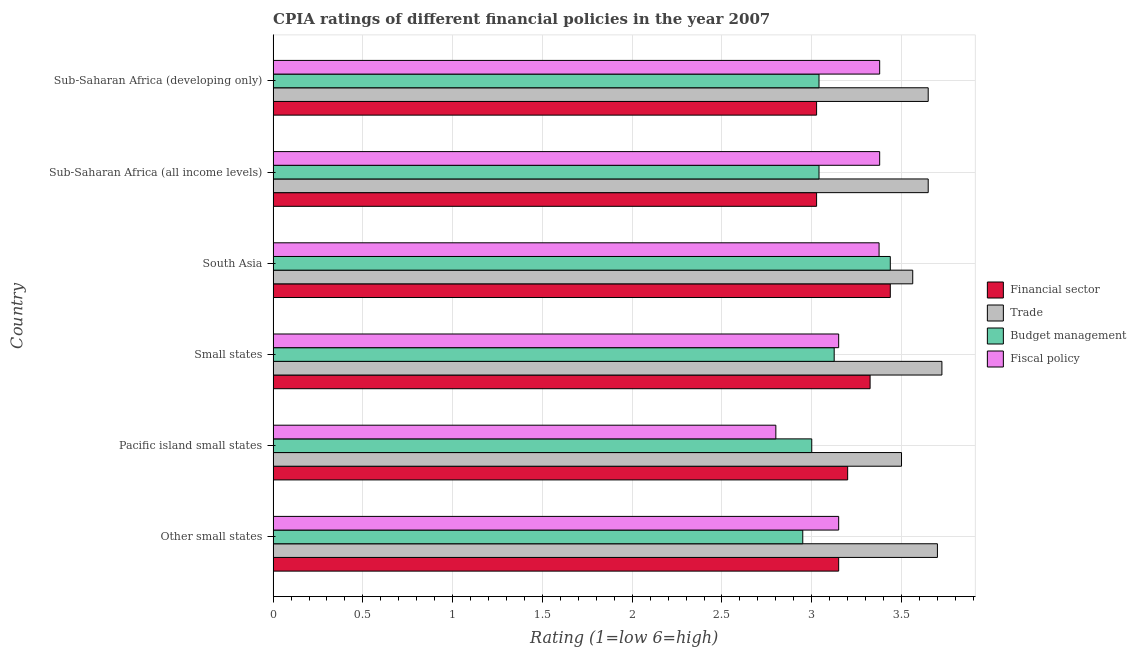How many different coloured bars are there?
Make the answer very short. 4. How many bars are there on the 5th tick from the top?
Offer a terse response. 4. How many bars are there on the 1st tick from the bottom?
Offer a very short reply. 4. What is the label of the 3rd group of bars from the top?
Make the answer very short. South Asia. In how many cases, is the number of bars for a given country not equal to the number of legend labels?
Your answer should be compact. 0. What is the cpia rating of financial sector in Small states?
Give a very brief answer. 3.33. Across all countries, what is the maximum cpia rating of trade?
Give a very brief answer. 3.73. In which country was the cpia rating of fiscal policy maximum?
Give a very brief answer. Sub-Saharan Africa (all income levels). In which country was the cpia rating of fiscal policy minimum?
Your response must be concise. Pacific island small states. What is the total cpia rating of trade in the graph?
Keep it short and to the point. 21.78. What is the difference between the cpia rating of financial sector in Pacific island small states and that in Small states?
Offer a very short reply. -0.12. What is the difference between the cpia rating of budget management in Sub-Saharan Africa (developing only) and the cpia rating of trade in Other small states?
Keep it short and to the point. -0.66. What is the average cpia rating of trade per country?
Offer a terse response. 3.63. What is the difference between the cpia rating of financial sector and cpia rating of budget management in Sub-Saharan Africa (all income levels)?
Provide a succinct answer. -0.01. What is the ratio of the cpia rating of trade in South Asia to that in Sub-Saharan Africa (developing only)?
Make the answer very short. 0.98. What is the difference between the highest and the second highest cpia rating of fiscal policy?
Offer a terse response. 0. What is the difference between the highest and the lowest cpia rating of fiscal policy?
Your answer should be very brief. 0.58. Is the sum of the cpia rating of financial sector in South Asia and Sub-Saharan Africa (developing only) greater than the maximum cpia rating of fiscal policy across all countries?
Give a very brief answer. Yes. What does the 1st bar from the top in Other small states represents?
Make the answer very short. Fiscal policy. What does the 4th bar from the bottom in Other small states represents?
Your answer should be very brief. Fiscal policy. Is it the case that in every country, the sum of the cpia rating of financial sector and cpia rating of trade is greater than the cpia rating of budget management?
Offer a terse response. Yes. How many bars are there?
Provide a succinct answer. 24. Are all the bars in the graph horizontal?
Keep it short and to the point. Yes. Are the values on the major ticks of X-axis written in scientific E-notation?
Provide a succinct answer. No. What is the title of the graph?
Provide a succinct answer. CPIA ratings of different financial policies in the year 2007. What is the label or title of the Y-axis?
Provide a succinct answer. Country. What is the Rating (1=low 6=high) in Financial sector in Other small states?
Give a very brief answer. 3.15. What is the Rating (1=low 6=high) of Trade in Other small states?
Provide a short and direct response. 3.7. What is the Rating (1=low 6=high) in Budget management in Other small states?
Provide a succinct answer. 2.95. What is the Rating (1=low 6=high) of Fiscal policy in Other small states?
Provide a short and direct response. 3.15. What is the Rating (1=low 6=high) of Trade in Pacific island small states?
Your answer should be very brief. 3.5. What is the Rating (1=low 6=high) in Fiscal policy in Pacific island small states?
Ensure brevity in your answer.  2.8. What is the Rating (1=low 6=high) in Financial sector in Small states?
Your answer should be very brief. 3.33. What is the Rating (1=low 6=high) of Trade in Small states?
Offer a terse response. 3.73. What is the Rating (1=low 6=high) of Budget management in Small states?
Keep it short and to the point. 3.12. What is the Rating (1=low 6=high) of Fiscal policy in Small states?
Keep it short and to the point. 3.15. What is the Rating (1=low 6=high) of Financial sector in South Asia?
Make the answer very short. 3.44. What is the Rating (1=low 6=high) in Trade in South Asia?
Keep it short and to the point. 3.56. What is the Rating (1=low 6=high) in Budget management in South Asia?
Give a very brief answer. 3.44. What is the Rating (1=low 6=high) in Fiscal policy in South Asia?
Provide a succinct answer. 3.38. What is the Rating (1=low 6=high) of Financial sector in Sub-Saharan Africa (all income levels)?
Make the answer very short. 3.03. What is the Rating (1=low 6=high) of Trade in Sub-Saharan Africa (all income levels)?
Give a very brief answer. 3.65. What is the Rating (1=low 6=high) in Budget management in Sub-Saharan Africa (all income levels)?
Make the answer very short. 3.04. What is the Rating (1=low 6=high) of Fiscal policy in Sub-Saharan Africa (all income levels)?
Provide a succinct answer. 3.38. What is the Rating (1=low 6=high) of Financial sector in Sub-Saharan Africa (developing only)?
Keep it short and to the point. 3.03. What is the Rating (1=low 6=high) of Trade in Sub-Saharan Africa (developing only)?
Ensure brevity in your answer.  3.65. What is the Rating (1=low 6=high) in Budget management in Sub-Saharan Africa (developing only)?
Your answer should be very brief. 3.04. What is the Rating (1=low 6=high) in Fiscal policy in Sub-Saharan Africa (developing only)?
Ensure brevity in your answer.  3.38. Across all countries, what is the maximum Rating (1=low 6=high) in Financial sector?
Your answer should be very brief. 3.44. Across all countries, what is the maximum Rating (1=low 6=high) in Trade?
Your response must be concise. 3.73. Across all countries, what is the maximum Rating (1=low 6=high) in Budget management?
Your answer should be compact. 3.44. Across all countries, what is the maximum Rating (1=low 6=high) of Fiscal policy?
Offer a very short reply. 3.38. Across all countries, what is the minimum Rating (1=low 6=high) in Financial sector?
Make the answer very short. 3.03. Across all countries, what is the minimum Rating (1=low 6=high) of Trade?
Offer a terse response. 3.5. Across all countries, what is the minimum Rating (1=low 6=high) in Budget management?
Your answer should be compact. 2.95. What is the total Rating (1=low 6=high) of Financial sector in the graph?
Make the answer very short. 19.17. What is the total Rating (1=low 6=high) in Trade in the graph?
Your response must be concise. 21.78. What is the total Rating (1=low 6=high) of Budget management in the graph?
Make the answer very short. 18.59. What is the total Rating (1=low 6=high) of Fiscal policy in the graph?
Offer a terse response. 19.23. What is the difference between the Rating (1=low 6=high) of Financial sector in Other small states and that in Pacific island small states?
Your answer should be compact. -0.05. What is the difference between the Rating (1=low 6=high) of Trade in Other small states and that in Pacific island small states?
Your response must be concise. 0.2. What is the difference between the Rating (1=low 6=high) of Fiscal policy in Other small states and that in Pacific island small states?
Your answer should be compact. 0.35. What is the difference between the Rating (1=low 6=high) of Financial sector in Other small states and that in Small states?
Ensure brevity in your answer.  -0.17. What is the difference between the Rating (1=low 6=high) of Trade in Other small states and that in Small states?
Provide a short and direct response. -0.03. What is the difference between the Rating (1=low 6=high) in Budget management in Other small states and that in Small states?
Give a very brief answer. -0.17. What is the difference between the Rating (1=low 6=high) of Financial sector in Other small states and that in South Asia?
Keep it short and to the point. -0.29. What is the difference between the Rating (1=low 6=high) in Trade in Other small states and that in South Asia?
Your answer should be compact. 0.14. What is the difference between the Rating (1=low 6=high) in Budget management in Other small states and that in South Asia?
Your response must be concise. -0.49. What is the difference between the Rating (1=low 6=high) of Fiscal policy in Other small states and that in South Asia?
Your answer should be compact. -0.23. What is the difference between the Rating (1=low 6=high) of Financial sector in Other small states and that in Sub-Saharan Africa (all income levels)?
Offer a very short reply. 0.12. What is the difference between the Rating (1=low 6=high) of Trade in Other small states and that in Sub-Saharan Africa (all income levels)?
Provide a succinct answer. 0.05. What is the difference between the Rating (1=low 6=high) in Budget management in Other small states and that in Sub-Saharan Africa (all income levels)?
Ensure brevity in your answer.  -0.09. What is the difference between the Rating (1=low 6=high) of Fiscal policy in Other small states and that in Sub-Saharan Africa (all income levels)?
Make the answer very short. -0.23. What is the difference between the Rating (1=low 6=high) in Financial sector in Other small states and that in Sub-Saharan Africa (developing only)?
Give a very brief answer. 0.12. What is the difference between the Rating (1=low 6=high) in Trade in Other small states and that in Sub-Saharan Africa (developing only)?
Provide a short and direct response. 0.05. What is the difference between the Rating (1=low 6=high) of Budget management in Other small states and that in Sub-Saharan Africa (developing only)?
Offer a very short reply. -0.09. What is the difference between the Rating (1=low 6=high) in Fiscal policy in Other small states and that in Sub-Saharan Africa (developing only)?
Ensure brevity in your answer.  -0.23. What is the difference between the Rating (1=low 6=high) of Financial sector in Pacific island small states and that in Small states?
Your answer should be compact. -0.12. What is the difference between the Rating (1=low 6=high) in Trade in Pacific island small states and that in Small states?
Your answer should be compact. -0.23. What is the difference between the Rating (1=low 6=high) in Budget management in Pacific island small states and that in Small states?
Make the answer very short. -0.12. What is the difference between the Rating (1=low 6=high) of Fiscal policy in Pacific island small states and that in Small states?
Give a very brief answer. -0.35. What is the difference between the Rating (1=low 6=high) in Financial sector in Pacific island small states and that in South Asia?
Keep it short and to the point. -0.24. What is the difference between the Rating (1=low 6=high) of Trade in Pacific island small states and that in South Asia?
Make the answer very short. -0.06. What is the difference between the Rating (1=low 6=high) in Budget management in Pacific island small states and that in South Asia?
Ensure brevity in your answer.  -0.44. What is the difference between the Rating (1=low 6=high) of Fiscal policy in Pacific island small states and that in South Asia?
Your answer should be compact. -0.57. What is the difference between the Rating (1=low 6=high) in Financial sector in Pacific island small states and that in Sub-Saharan Africa (all income levels)?
Ensure brevity in your answer.  0.17. What is the difference between the Rating (1=low 6=high) in Trade in Pacific island small states and that in Sub-Saharan Africa (all income levels)?
Your answer should be compact. -0.15. What is the difference between the Rating (1=low 6=high) in Budget management in Pacific island small states and that in Sub-Saharan Africa (all income levels)?
Your answer should be compact. -0.04. What is the difference between the Rating (1=low 6=high) of Fiscal policy in Pacific island small states and that in Sub-Saharan Africa (all income levels)?
Offer a very short reply. -0.58. What is the difference between the Rating (1=low 6=high) of Financial sector in Pacific island small states and that in Sub-Saharan Africa (developing only)?
Your answer should be very brief. 0.17. What is the difference between the Rating (1=low 6=high) of Trade in Pacific island small states and that in Sub-Saharan Africa (developing only)?
Offer a very short reply. -0.15. What is the difference between the Rating (1=low 6=high) of Budget management in Pacific island small states and that in Sub-Saharan Africa (developing only)?
Your answer should be compact. -0.04. What is the difference between the Rating (1=low 6=high) in Fiscal policy in Pacific island small states and that in Sub-Saharan Africa (developing only)?
Offer a very short reply. -0.58. What is the difference between the Rating (1=low 6=high) of Financial sector in Small states and that in South Asia?
Keep it short and to the point. -0.11. What is the difference between the Rating (1=low 6=high) in Trade in Small states and that in South Asia?
Provide a short and direct response. 0.16. What is the difference between the Rating (1=low 6=high) of Budget management in Small states and that in South Asia?
Your answer should be compact. -0.31. What is the difference between the Rating (1=low 6=high) of Fiscal policy in Small states and that in South Asia?
Your response must be concise. -0.23. What is the difference between the Rating (1=low 6=high) in Financial sector in Small states and that in Sub-Saharan Africa (all income levels)?
Make the answer very short. 0.3. What is the difference between the Rating (1=low 6=high) of Trade in Small states and that in Sub-Saharan Africa (all income levels)?
Ensure brevity in your answer.  0.08. What is the difference between the Rating (1=low 6=high) in Budget management in Small states and that in Sub-Saharan Africa (all income levels)?
Offer a terse response. 0.08. What is the difference between the Rating (1=low 6=high) of Fiscal policy in Small states and that in Sub-Saharan Africa (all income levels)?
Provide a succinct answer. -0.23. What is the difference between the Rating (1=low 6=high) of Financial sector in Small states and that in Sub-Saharan Africa (developing only)?
Offer a very short reply. 0.3. What is the difference between the Rating (1=low 6=high) in Trade in Small states and that in Sub-Saharan Africa (developing only)?
Give a very brief answer. 0.08. What is the difference between the Rating (1=low 6=high) in Budget management in Small states and that in Sub-Saharan Africa (developing only)?
Your answer should be compact. 0.08. What is the difference between the Rating (1=low 6=high) of Fiscal policy in Small states and that in Sub-Saharan Africa (developing only)?
Provide a short and direct response. -0.23. What is the difference between the Rating (1=low 6=high) of Financial sector in South Asia and that in Sub-Saharan Africa (all income levels)?
Offer a very short reply. 0.41. What is the difference between the Rating (1=low 6=high) of Trade in South Asia and that in Sub-Saharan Africa (all income levels)?
Your answer should be very brief. -0.09. What is the difference between the Rating (1=low 6=high) of Budget management in South Asia and that in Sub-Saharan Africa (all income levels)?
Make the answer very short. 0.4. What is the difference between the Rating (1=low 6=high) of Fiscal policy in South Asia and that in Sub-Saharan Africa (all income levels)?
Provide a short and direct response. -0. What is the difference between the Rating (1=low 6=high) of Financial sector in South Asia and that in Sub-Saharan Africa (developing only)?
Keep it short and to the point. 0.41. What is the difference between the Rating (1=low 6=high) of Trade in South Asia and that in Sub-Saharan Africa (developing only)?
Your answer should be very brief. -0.09. What is the difference between the Rating (1=low 6=high) of Budget management in South Asia and that in Sub-Saharan Africa (developing only)?
Your answer should be very brief. 0.4. What is the difference between the Rating (1=low 6=high) of Fiscal policy in South Asia and that in Sub-Saharan Africa (developing only)?
Make the answer very short. -0. What is the difference between the Rating (1=low 6=high) of Financial sector in Sub-Saharan Africa (all income levels) and that in Sub-Saharan Africa (developing only)?
Offer a very short reply. 0. What is the difference between the Rating (1=low 6=high) of Trade in Sub-Saharan Africa (all income levels) and that in Sub-Saharan Africa (developing only)?
Your answer should be very brief. 0. What is the difference between the Rating (1=low 6=high) of Financial sector in Other small states and the Rating (1=low 6=high) of Trade in Pacific island small states?
Make the answer very short. -0.35. What is the difference between the Rating (1=low 6=high) of Financial sector in Other small states and the Rating (1=low 6=high) of Fiscal policy in Pacific island small states?
Offer a terse response. 0.35. What is the difference between the Rating (1=low 6=high) in Trade in Other small states and the Rating (1=low 6=high) in Fiscal policy in Pacific island small states?
Your answer should be very brief. 0.9. What is the difference between the Rating (1=low 6=high) in Budget management in Other small states and the Rating (1=low 6=high) in Fiscal policy in Pacific island small states?
Provide a short and direct response. 0.15. What is the difference between the Rating (1=low 6=high) in Financial sector in Other small states and the Rating (1=low 6=high) in Trade in Small states?
Your answer should be very brief. -0.57. What is the difference between the Rating (1=low 6=high) of Financial sector in Other small states and the Rating (1=low 6=high) of Budget management in Small states?
Give a very brief answer. 0.03. What is the difference between the Rating (1=low 6=high) in Financial sector in Other small states and the Rating (1=low 6=high) in Fiscal policy in Small states?
Provide a succinct answer. 0. What is the difference between the Rating (1=low 6=high) of Trade in Other small states and the Rating (1=low 6=high) of Budget management in Small states?
Make the answer very short. 0.57. What is the difference between the Rating (1=low 6=high) in Trade in Other small states and the Rating (1=low 6=high) in Fiscal policy in Small states?
Provide a succinct answer. 0.55. What is the difference between the Rating (1=low 6=high) of Budget management in Other small states and the Rating (1=low 6=high) of Fiscal policy in Small states?
Provide a succinct answer. -0.2. What is the difference between the Rating (1=low 6=high) in Financial sector in Other small states and the Rating (1=low 6=high) in Trade in South Asia?
Make the answer very short. -0.41. What is the difference between the Rating (1=low 6=high) of Financial sector in Other small states and the Rating (1=low 6=high) of Budget management in South Asia?
Your answer should be compact. -0.29. What is the difference between the Rating (1=low 6=high) of Financial sector in Other small states and the Rating (1=low 6=high) of Fiscal policy in South Asia?
Offer a very short reply. -0.23. What is the difference between the Rating (1=low 6=high) of Trade in Other small states and the Rating (1=low 6=high) of Budget management in South Asia?
Ensure brevity in your answer.  0.26. What is the difference between the Rating (1=low 6=high) of Trade in Other small states and the Rating (1=low 6=high) of Fiscal policy in South Asia?
Your answer should be compact. 0.33. What is the difference between the Rating (1=low 6=high) in Budget management in Other small states and the Rating (1=low 6=high) in Fiscal policy in South Asia?
Ensure brevity in your answer.  -0.42. What is the difference between the Rating (1=low 6=high) in Financial sector in Other small states and the Rating (1=low 6=high) in Trade in Sub-Saharan Africa (all income levels)?
Provide a succinct answer. -0.5. What is the difference between the Rating (1=low 6=high) of Financial sector in Other small states and the Rating (1=low 6=high) of Budget management in Sub-Saharan Africa (all income levels)?
Offer a very short reply. 0.11. What is the difference between the Rating (1=low 6=high) of Financial sector in Other small states and the Rating (1=low 6=high) of Fiscal policy in Sub-Saharan Africa (all income levels)?
Offer a terse response. -0.23. What is the difference between the Rating (1=low 6=high) of Trade in Other small states and the Rating (1=low 6=high) of Budget management in Sub-Saharan Africa (all income levels)?
Provide a short and direct response. 0.66. What is the difference between the Rating (1=low 6=high) in Trade in Other small states and the Rating (1=low 6=high) in Fiscal policy in Sub-Saharan Africa (all income levels)?
Provide a succinct answer. 0.32. What is the difference between the Rating (1=low 6=high) of Budget management in Other small states and the Rating (1=low 6=high) of Fiscal policy in Sub-Saharan Africa (all income levels)?
Make the answer very short. -0.43. What is the difference between the Rating (1=low 6=high) of Financial sector in Other small states and the Rating (1=low 6=high) of Trade in Sub-Saharan Africa (developing only)?
Ensure brevity in your answer.  -0.5. What is the difference between the Rating (1=low 6=high) of Financial sector in Other small states and the Rating (1=low 6=high) of Budget management in Sub-Saharan Africa (developing only)?
Your response must be concise. 0.11. What is the difference between the Rating (1=low 6=high) of Financial sector in Other small states and the Rating (1=low 6=high) of Fiscal policy in Sub-Saharan Africa (developing only)?
Offer a very short reply. -0.23. What is the difference between the Rating (1=low 6=high) of Trade in Other small states and the Rating (1=low 6=high) of Budget management in Sub-Saharan Africa (developing only)?
Give a very brief answer. 0.66. What is the difference between the Rating (1=low 6=high) of Trade in Other small states and the Rating (1=low 6=high) of Fiscal policy in Sub-Saharan Africa (developing only)?
Make the answer very short. 0.32. What is the difference between the Rating (1=low 6=high) of Budget management in Other small states and the Rating (1=low 6=high) of Fiscal policy in Sub-Saharan Africa (developing only)?
Your response must be concise. -0.43. What is the difference between the Rating (1=low 6=high) of Financial sector in Pacific island small states and the Rating (1=low 6=high) of Trade in Small states?
Your answer should be compact. -0.53. What is the difference between the Rating (1=low 6=high) of Financial sector in Pacific island small states and the Rating (1=low 6=high) of Budget management in Small states?
Give a very brief answer. 0.07. What is the difference between the Rating (1=low 6=high) in Financial sector in Pacific island small states and the Rating (1=low 6=high) in Fiscal policy in Small states?
Provide a succinct answer. 0.05. What is the difference between the Rating (1=low 6=high) in Budget management in Pacific island small states and the Rating (1=low 6=high) in Fiscal policy in Small states?
Provide a succinct answer. -0.15. What is the difference between the Rating (1=low 6=high) in Financial sector in Pacific island small states and the Rating (1=low 6=high) in Trade in South Asia?
Ensure brevity in your answer.  -0.36. What is the difference between the Rating (1=low 6=high) in Financial sector in Pacific island small states and the Rating (1=low 6=high) in Budget management in South Asia?
Provide a short and direct response. -0.24. What is the difference between the Rating (1=low 6=high) of Financial sector in Pacific island small states and the Rating (1=low 6=high) of Fiscal policy in South Asia?
Offer a terse response. -0.17. What is the difference between the Rating (1=low 6=high) in Trade in Pacific island small states and the Rating (1=low 6=high) in Budget management in South Asia?
Give a very brief answer. 0.06. What is the difference between the Rating (1=low 6=high) in Budget management in Pacific island small states and the Rating (1=low 6=high) in Fiscal policy in South Asia?
Your answer should be very brief. -0.38. What is the difference between the Rating (1=low 6=high) in Financial sector in Pacific island small states and the Rating (1=low 6=high) in Trade in Sub-Saharan Africa (all income levels)?
Offer a terse response. -0.45. What is the difference between the Rating (1=low 6=high) in Financial sector in Pacific island small states and the Rating (1=low 6=high) in Budget management in Sub-Saharan Africa (all income levels)?
Provide a succinct answer. 0.16. What is the difference between the Rating (1=low 6=high) in Financial sector in Pacific island small states and the Rating (1=low 6=high) in Fiscal policy in Sub-Saharan Africa (all income levels)?
Your answer should be compact. -0.18. What is the difference between the Rating (1=low 6=high) of Trade in Pacific island small states and the Rating (1=low 6=high) of Budget management in Sub-Saharan Africa (all income levels)?
Offer a very short reply. 0.46. What is the difference between the Rating (1=low 6=high) in Trade in Pacific island small states and the Rating (1=low 6=high) in Fiscal policy in Sub-Saharan Africa (all income levels)?
Your answer should be compact. 0.12. What is the difference between the Rating (1=low 6=high) of Budget management in Pacific island small states and the Rating (1=low 6=high) of Fiscal policy in Sub-Saharan Africa (all income levels)?
Offer a very short reply. -0.38. What is the difference between the Rating (1=low 6=high) in Financial sector in Pacific island small states and the Rating (1=low 6=high) in Trade in Sub-Saharan Africa (developing only)?
Your answer should be very brief. -0.45. What is the difference between the Rating (1=low 6=high) of Financial sector in Pacific island small states and the Rating (1=low 6=high) of Budget management in Sub-Saharan Africa (developing only)?
Offer a terse response. 0.16. What is the difference between the Rating (1=low 6=high) in Financial sector in Pacific island small states and the Rating (1=low 6=high) in Fiscal policy in Sub-Saharan Africa (developing only)?
Offer a very short reply. -0.18. What is the difference between the Rating (1=low 6=high) in Trade in Pacific island small states and the Rating (1=low 6=high) in Budget management in Sub-Saharan Africa (developing only)?
Ensure brevity in your answer.  0.46. What is the difference between the Rating (1=low 6=high) of Trade in Pacific island small states and the Rating (1=low 6=high) of Fiscal policy in Sub-Saharan Africa (developing only)?
Ensure brevity in your answer.  0.12. What is the difference between the Rating (1=low 6=high) in Budget management in Pacific island small states and the Rating (1=low 6=high) in Fiscal policy in Sub-Saharan Africa (developing only)?
Provide a short and direct response. -0.38. What is the difference between the Rating (1=low 6=high) of Financial sector in Small states and the Rating (1=low 6=high) of Trade in South Asia?
Give a very brief answer. -0.24. What is the difference between the Rating (1=low 6=high) in Financial sector in Small states and the Rating (1=low 6=high) in Budget management in South Asia?
Provide a short and direct response. -0.11. What is the difference between the Rating (1=low 6=high) in Financial sector in Small states and the Rating (1=low 6=high) in Fiscal policy in South Asia?
Give a very brief answer. -0.05. What is the difference between the Rating (1=low 6=high) in Trade in Small states and the Rating (1=low 6=high) in Budget management in South Asia?
Your response must be concise. 0.29. What is the difference between the Rating (1=low 6=high) of Budget management in Small states and the Rating (1=low 6=high) of Fiscal policy in South Asia?
Offer a very short reply. -0.25. What is the difference between the Rating (1=low 6=high) of Financial sector in Small states and the Rating (1=low 6=high) of Trade in Sub-Saharan Africa (all income levels)?
Make the answer very short. -0.32. What is the difference between the Rating (1=low 6=high) of Financial sector in Small states and the Rating (1=low 6=high) of Budget management in Sub-Saharan Africa (all income levels)?
Give a very brief answer. 0.28. What is the difference between the Rating (1=low 6=high) in Financial sector in Small states and the Rating (1=low 6=high) in Fiscal policy in Sub-Saharan Africa (all income levels)?
Offer a terse response. -0.05. What is the difference between the Rating (1=low 6=high) in Trade in Small states and the Rating (1=low 6=high) in Budget management in Sub-Saharan Africa (all income levels)?
Your response must be concise. 0.68. What is the difference between the Rating (1=low 6=high) of Trade in Small states and the Rating (1=low 6=high) of Fiscal policy in Sub-Saharan Africa (all income levels)?
Make the answer very short. 0.35. What is the difference between the Rating (1=low 6=high) of Budget management in Small states and the Rating (1=low 6=high) of Fiscal policy in Sub-Saharan Africa (all income levels)?
Provide a succinct answer. -0.25. What is the difference between the Rating (1=low 6=high) in Financial sector in Small states and the Rating (1=low 6=high) in Trade in Sub-Saharan Africa (developing only)?
Offer a very short reply. -0.32. What is the difference between the Rating (1=low 6=high) of Financial sector in Small states and the Rating (1=low 6=high) of Budget management in Sub-Saharan Africa (developing only)?
Offer a terse response. 0.28. What is the difference between the Rating (1=low 6=high) in Financial sector in Small states and the Rating (1=low 6=high) in Fiscal policy in Sub-Saharan Africa (developing only)?
Your answer should be very brief. -0.05. What is the difference between the Rating (1=low 6=high) in Trade in Small states and the Rating (1=low 6=high) in Budget management in Sub-Saharan Africa (developing only)?
Provide a short and direct response. 0.68. What is the difference between the Rating (1=low 6=high) in Trade in Small states and the Rating (1=low 6=high) in Fiscal policy in Sub-Saharan Africa (developing only)?
Your answer should be very brief. 0.35. What is the difference between the Rating (1=low 6=high) of Budget management in Small states and the Rating (1=low 6=high) of Fiscal policy in Sub-Saharan Africa (developing only)?
Keep it short and to the point. -0.25. What is the difference between the Rating (1=low 6=high) in Financial sector in South Asia and the Rating (1=low 6=high) in Trade in Sub-Saharan Africa (all income levels)?
Offer a terse response. -0.21. What is the difference between the Rating (1=low 6=high) of Financial sector in South Asia and the Rating (1=low 6=high) of Budget management in Sub-Saharan Africa (all income levels)?
Provide a succinct answer. 0.4. What is the difference between the Rating (1=low 6=high) in Financial sector in South Asia and the Rating (1=low 6=high) in Fiscal policy in Sub-Saharan Africa (all income levels)?
Make the answer very short. 0.06. What is the difference between the Rating (1=low 6=high) in Trade in South Asia and the Rating (1=low 6=high) in Budget management in Sub-Saharan Africa (all income levels)?
Offer a very short reply. 0.52. What is the difference between the Rating (1=low 6=high) in Trade in South Asia and the Rating (1=low 6=high) in Fiscal policy in Sub-Saharan Africa (all income levels)?
Provide a succinct answer. 0.18. What is the difference between the Rating (1=low 6=high) in Budget management in South Asia and the Rating (1=low 6=high) in Fiscal policy in Sub-Saharan Africa (all income levels)?
Offer a very short reply. 0.06. What is the difference between the Rating (1=low 6=high) in Financial sector in South Asia and the Rating (1=low 6=high) in Trade in Sub-Saharan Africa (developing only)?
Your answer should be compact. -0.21. What is the difference between the Rating (1=low 6=high) in Financial sector in South Asia and the Rating (1=low 6=high) in Budget management in Sub-Saharan Africa (developing only)?
Keep it short and to the point. 0.4. What is the difference between the Rating (1=low 6=high) in Financial sector in South Asia and the Rating (1=low 6=high) in Fiscal policy in Sub-Saharan Africa (developing only)?
Offer a very short reply. 0.06. What is the difference between the Rating (1=low 6=high) of Trade in South Asia and the Rating (1=low 6=high) of Budget management in Sub-Saharan Africa (developing only)?
Provide a succinct answer. 0.52. What is the difference between the Rating (1=low 6=high) of Trade in South Asia and the Rating (1=low 6=high) of Fiscal policy in Sub-Saharan Africa (developing only)?
Provide a succinct answer. 0.18. What is the difference between the Rating (1=low 6=high) of Budget management in South Asia and the Rating (1=low 6=high) of Fiscal policy in Sub-Saharan Africa (developing only)?
Make the answer very short. 0.06. What is the difference between the Rating (1=low 6=high) of Financial sector in Sub-Saharan Africa (all income levels) and the Rating (1=low 6=high) of Trade in Sub-Saharan Africa (developing only)?
Keep it short and to the point. -0.62. What is the difference between the Rating (1=low 6=high) in Financial sector in Sub-Saharan Africa (all income levels) and the Rating (1=low 6=high) in Budget management in Sub-Saharan Africa (developing only)?
Your answer should be compact. -0.01. What is the difference between the Rating (1=low 6=high) in Financial sector in Sub-Saharan Africa (all income levels) and the Rating (1=low 6=high) in Fiscal policy in Sub-Saharan Africa (developing only)?
Your answer should be very brief. -0.35. What is the difference between the Rating (1=low 6=high) in Trade in Sub-Saharan Africa (all income levels) and the Rating (1=low 6=high) in Budget management in Sub-Saharan Africa (developing only)?
Provide a short and direct response. 0.61. What is the difference between the Rating (1=low 6=high) in Trade in Sub-Saharan Africa (all income levels) and the Rating (1=low 6=high) in Fiscal policy in Sub-Saharan Africa (developing only)?
Offer a terse response. 0.27. What is the difference between the Rating (1=low 6=high) in Budget management in Sub-Saharan Africa (all income levels) and the Rating (1=low 6=high) in Fiscal policy in Sub-Saharan Africa (developing only)?
Give a very brief answer. -0.34. What is the average Rating (1=low 6=high) of Financial sector per country?
Your response must be concise. 3.19. What is the average Rating (1=low 6=high) of Trade per country?
Offer a very short reply. 3.63. What is the average Rating (1=low 6=high) of Budget management per country?
Offer a very short reply. 3.1. What is the average Rating (1=low 6=high) of Fiscal policy per country?
Your answer should be very brief. 3.21. What is the difference between the Rating (1=low 6=high) in Financial sector and Rating (1=low 6=high) in Trade in Other small states?
Provide a short and direct response. -0.55. What is the difference between the Rating (1=low 6=high) in Trade and Rating (1=low 6=high) in Fiscal policy in Other small states?
Ensure brevity in your answer.  0.55. What is the difference between the Rating (1=low 6=high) of Budget management and Rating (1=low 6=high) of Fiscal policy in Other small states?
Your answer should be very brief. -0.2. What is the difference between the Rating (1=low 6=high) of Financial sector and Rating (1=low 6=high) of Fiscal policy in Pacific island small states?
Give a very brief answer. 0.4. What is the difference between the Rating (1=low 6=high) of Trade and Rating (1=low 6=high) of Fiscal policy in Pacific island small states?
Ensure brevity in your answer.  0.7. What is the difference between the Rating (1=low 6=high) of Financial sector and Rating (1=low 6=high) of Fiscal policy in Small states?
Your response must be concise. 0.17. What is the difference between the Rating (1=low 6=high) of Trade and Rating (1=low 6=high) of Budget management in Small states?
Your answer should be compact. 0.6. What is the difference between the Rating (1=low 6=high) of Trade and Rating (1=low 6=high) of Fiscal policy in Small states?
Make the answer very short. 0.57. What is the difference between the Rating (1=low 6=high) in Budget management and Rating (1=low 6=high) in Fiscal policy in Small states?
Make the answer very short. -0.03. What is the difference between the Rating (1=low 6=high) in Financial sector and Rating (1=low 6=high) in Trade in South Asia?
Offer a terse response. -0.12. What is the difference between the Rating (1=low 6=high) in Financial sector and Rating (1=low 6=high) in Fiscal policy in South Asia?
Keep it short and to the point. 0.06. What is the difference between the Rating (1=low 6=high) in Trade and Rating (1=low 6=high) in Budget management in South Asia?
Your response must be concise. 0.12. What is the difference between the Rating (1=low 6=high) of Trade and Rating (1=low 6=high) of Fiscal policy in South Asia?
Offer a terse response. 0.19. What is the difference between the Rating (1=low 6=high) of Budget management and Rating (1=low 6=high) of Fiscal policy in South Asia?
Provide a short and direct response. 0.06. What is the difference between the Rating (1=low 6=high) of Financial sector and Rating (1=low 6=high) of Trade in Sub-Saharan Africa (all income levels)?
Give a very brief answer. -0.62. What is the difference between the Rating (1=low 6=high) of Financial sector and Rating (1=low 6=high) of Budget management in Sub-Saharan Africa (all income levels)?
Provide a short and direct response. -0.01. What is the difference between the Rating (1=low 6=high) of Financial sector and Rating (1=low 6=high) of Fiscal policy in Sub-Saharan Africa (all income levels)?
Provide a succinct answer. -0.35. What is the difference between the Rating (1=low 6=high) in Trade and Rating (1=low 6=high) in Budget management in Sub-Saharan Africa (all income levels)?
Your answer should be compact. 0.61. What is the difference between the Rating (1=low 6=high) in Trade and Rating (1=low 6=high) in Fiscal policy in Sub-Saharan Africa (all income levels)?
Provide a short and direct response. 0.27. What is the difference between the Rating (1=low 6=high) of Budget management and Rating (1=low 6=high) of Fiscal policy in Sub-Saharan Africa (all income levels)?
Your answer should be very brief. -0.34. What is the difference between the Rating (1=low 6=high) of Financial sector and Rating (1=low 6=high) of Trade in Sub-Saharan Africa (developing only)?
Provide a short and direct response. -0.62. What is the difference between the Rating (1=low 6=high) in Financial sector and Rating (1=low 6=high) in Budget management in Sub-Saharan Africa (developing only)?
Provide a succinct answer. -0.01. What is the difference between the Rating (1=low 6=high) of Financial sector and Rating (1=low 6=high) of Fiscal policy in Sub-Saharan Africa (developing only)?
Your answer should be compact. -0.35. What is the difference between the Rating (1=low 6=high) in Trade and Rating (1=low 6=high) in Budget management in Sub-Saharan Africa (developing only)?
Your response must be concise. 0.61. What is the difference between the Rating (1=low 6=high) of Trade and Rating (1=low 6=high) of Fiscal policy in Sub-Saharan Africa (developing only)?
Give a very brief answer. 0.27. What is the difference between the Rating (1=low 6=high) in Budget management and Rating (1=low 6=high) in Fiscal policy in Sub-Saharan Africa (developing only)?
Your answer should be compact. -0.34. What is the ratio of the Rating (1=low 6=high) of Financial sector in Other small states to that in Pacific island small states?
Provide a short and direct response. 0.98. What is the ratio of the Rating (1=low 6=high) in Trade in Other small states to that in Pacific island small states?
Offer a terse response. 1.06. What is the ratio of the Rating (1=low 6=high) in Budget management in Other small states to that in Pacific island small states?
Your response must be concise. 0.98. What is the ratio of the Rating (1=low 6=high) in Financial sector in Other small states to that in Small states?
Provide a short and direct response. 0.95. What is the ratio of the Rating (1=low 6=high) of Budget management in Other small states to that in Small states?
Keep it short and to the point. 0.94. What is the ratio of the Rating (1=low 6=high) of Financial sector in Other small states to that in South Asia?
Offer a very short reply. 0.92. What is the ratio of the Rating (1=low 6=high) of Trade in Other small states to that in South Asia?
Ensure brevity in your answer.  1.04. What is the ratio of the Rating (1=low 6=high) of Budget management in Other small states to that in South Asia?
Offer a terse response. 0.86. What is the ratio of the Rating (1=low 6=high) in Financial sector in Other small states to that in Sub-Saharan Africa (all income levels)?
Your answer should be very brief. 1.04. What is the ratio of the Rating (1=low 6=high) of Trade in Other small states to that in Sub-Saharan Africa (all income levels)?
Ensure brevity in your answer.  1.01. What is the ratio of the Rating (1=low 6=high) in Budget management in Other small states to that in Sub-Saharan Africa (all income levels)?
Make the answer very short. 0.97. What is the ratio of the Rating (1=low 6=high) in Fiscal policy in Other small states to that in Sub-Saharan Africa (all income levels)?
Provide a short and direct response. 0.93. What is the ratio of the Rating (1=low 6=high) of Financial sector in Other small states to that in Sub-Saharan Africa (developing only)?
Provide a succinct answer. 1.04. What is the ratio of the Rating (1=low 6=high) of Trade in Other small states to that in Sub-Saharan Africa (developing only)?
Your answer should be very brief. 1.01. What is the ratio of the Rating (1=low 6=high) of Budget management in Other small states to that in Sub-Saharan Africa (developing only)?
Give a very brief answer. 0.97. What is the ratio of the Rating (1=low 6=high) in Fiscal policy in Other small states to that in Sub-Saharan Africa (developing only)?
Provide a succinct answer. 0.93. What is the ratio of the Rating (1=low 6=high) in Financial sector in Pacific island small states to that in Small states?
Your response must be concise. 0.96. What is the ratio of the Rating (1=low 6=high) in Trade in Pacific island small states to that in Small states?
Provide a short and direct response. 0.94. What is the ratio of the Rating (1=low 6=high) in Budget management in Pacific island small states to that in Small states?
Make the answer very short. 0.96. What is the ratio of the Rating (1=low 6=high) of Fiscal policy in Pacific island small states to that in Small states?
Provide a short and direct response. 0.89. What is the ratio of the Rating (1=low 6=high) of Financial sector in Pacific island small states to that in South Asia?
Your response must be concise. 0.93. What is the ratio of the Rating (1=low 6=high) in Trade in Pacific island small states to that in South Asia?
Provide a succinct answer. 0.98. What is the ratio of the Rating (1=low 6=high) in Budget management in Pacific island small states to that in South Asia?
Provide a succinct answer. 0.87. What is the ratio of the Rating (1=low 6=high) of Fiscal policy in Pacific island small states to that in South Asia?
Your answer should be compact. 0.83. What is the ratio of the Rating (1=low 6=high) of Financial sector in Pacific island small states to that in Sub-Saharan Africa (all income levels)?
Provide a succinct answer. 1.06. What is the ratio of the Rating (1=low 6=high) in Trade in Pacific island small states to that in Sub-Saharan Africa (all income levels)?
Provide a succinct answer. 0.96. What is the ratio of the Rating (1=low 6=high) of Budget management in Pacific island small states to that in Sub-Saharan Africa (all income levels)?
Make the answer very short. 0.99. What is the ratio of the Rating (1=low 6=high) in Fiscal policy in Pacific island small states to that in Sub-Saharan Africa (all income levels)?
Your response must be concise. 0.83. What is the ratio of the Rating (1=low 6=high) of Financial sector in Pacific island small states to that in Sub-Saharan Africa (developing only)?
Your response must be concise. 1.06. What is the ratio of the Rating (1=low 6=high) in Trade in Pacific island small states to that in Sub-Saharan Africa (developing only)?
Your answer should be very brief. 0.96. What is the ratio of the Rating (1=low 6=high) in Budget management in Pacific island small states to that in Sub-Saharan Africa (developing only)?
Your answer should be compact. 0.99. What is the ratio of the Rating (1=low 6=high) in Fiscal policy in Pacific island small states to that in Sub-Saharan Africa (developing only)?
Make the answer very short. 0.83. What is the ratio of the Rating (1=low 6=high) of Financial sector in Small states to that in South Asia?
Ensure brevity in your answer.  0.97. What is the ratio of the Rating (1=low 6=high) in Trade in Small states to that in South Asia?
Offer a very short reply. 1.05. What is the ratio of the Rating (1=low 6=high) in Financial sector in Small states to that in Sub-Saharan Africa (all income levels)?
Provide a short and direct response. 1.1. What is the ratio of the Rating (1=low 6=high) of Trade in Small states to that in Sub-Saharan Africa (all income levels)?
Your response must be concise. 1.02. What is the ratio of the Rating (1=low 6=high) in Budget management in Small states to that in Sub-Saharan Africa (all income levels)?
Provide a succinct answer. 1.03. What is the ratio of the Rating (1=low 6=high) of Fiscal policy in Small states to that in Sub-Saharan Africa (all income levels)?
Offer a very short reply. 0.93. What is the ratio of the Rating (1=low 6=high) of Financial sector in Small states to that in Sub-Saharan Africa (developing only)?
Provide a short and direct response. 1.1. What is the ratio of the Rating (1=low 6=high) of Trade in Small states to that in Sub-Saharan Africa (developing only)?
Ensure brevity in your answer.  1.02. What is the ratio of the Rating (1=low 6=high) in Budget management in Small states to that in Sub-Saharan Africa (developing only)?
Offer a terse response. 1.03. What is the ratio of the Rating (1=low 6=high) of Fiscal policy in Small states to that in Sub-Saharan Africa (developing only)?
Your response must be concise. 0.93. What is the ratio of the Rating (1=low 6=high) in Financial sector in South Asia to that in Sub-Saharan Africa (all income levels)?
Offer a very short reply. 1.14. What is the ratio of the Rating (1=low 6=high) of Trade in South Asia to that in Sub-Saharan Africa (all income levels)?
Provide a succinct answer. 0.98. What is the ratio of the Rating (1=low 6=high) in Budget management in South Asia to that in Sub-Saharan Africa (all income levels)?
Your answer should be very brief. 1.13. What is the ratio of the Rating (1=low 6=high) of Financial sector in South Asia to that in Sub-Saharan Africa (developing only)?
Give a very brief answer. 1.14. What is the ratio of the Rating (1=low 6=high) in Trade in South Asia to that in Sub-Saharan Africa (developing only)?
Ensure brevity in your answer.  0.98. What is the ratio of the Rating (1=low 6=high) of Budget management in South Asia to that in Sub-Saharan Africa (developing only)?
Make the answer very short. 1.13. What is the ratio of the Rating (1=low 6=high) in Fiscal policy in South Asia to that in Sub-Saharan Africa (developing only)?
Your answer should be very brief. 1. What is the difference between the highest and the second highest Rating (1=low 6=high) in Financial sector?
Keep it short and to the point. 0.11. What is the difference between the highest and the second highest Rating (1=low 6=high) in Trade?
Offer a very short reply. 0.03. What is the difference between the highest and the second highest Rating (1=low 6=high) in Budget management?
Provide a short and direct response. 0.31. What is the difference between the highest and the second highest Rating (1=low 6=high) in Fiscal policy?
Your response must be concise. 0. What is the difference between the highest and the lowest Rating (1=low 6=high) in Financial sector?
Your answer should be very brief. 0.41. What is the difference between the highest and the lowest Rating (1=low 6=high) of Trade?
Offer a very short reply. 0.23. What is the difference between the highest and the lowest Rating (1=low 6=high) in Budget management?
Give a very brief answer. 0.49. What is the difference between the highest and the lowest Rating (1=low 6=high) of Fiscal policy?
Offer a terse response. 0.58. 